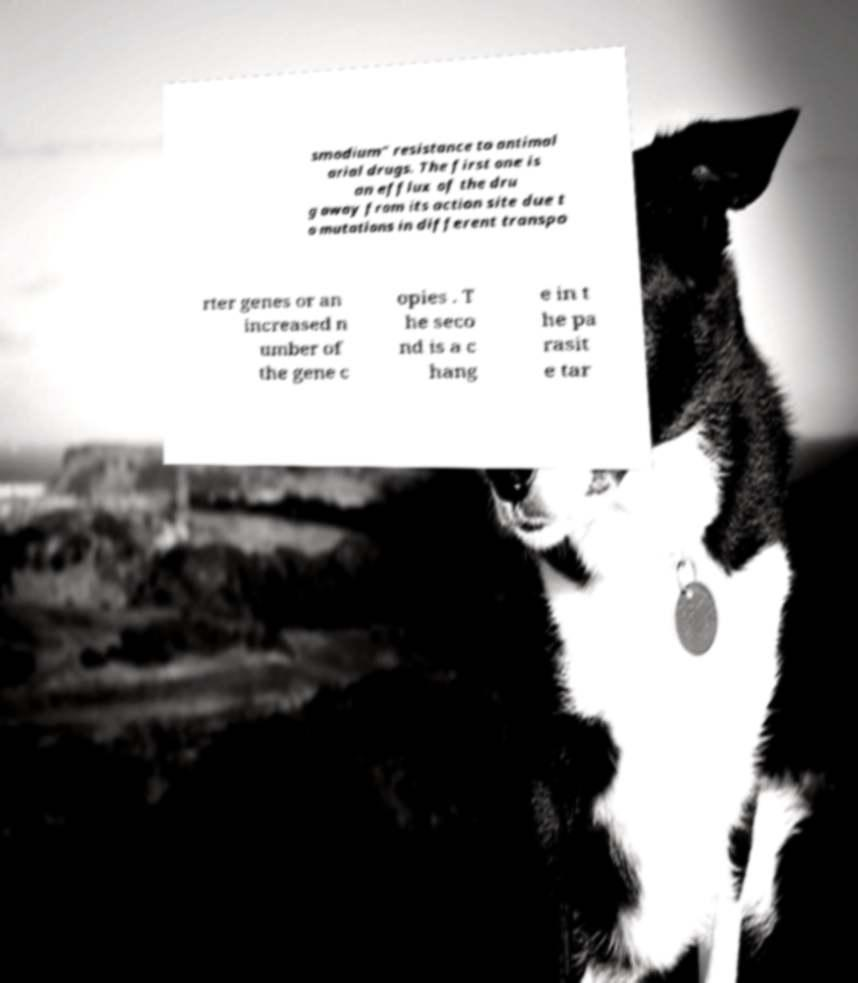Can you accurately transcribe the text from the provided image for me? smodium" resistance to antimal arial drugs. The first one is an efflux of the dru g away from its action site due t o mutations in different transpo rter genes or an increased n umber of the gene c opies . T he seco nd is a c hang e in t he pa rasit e tar 